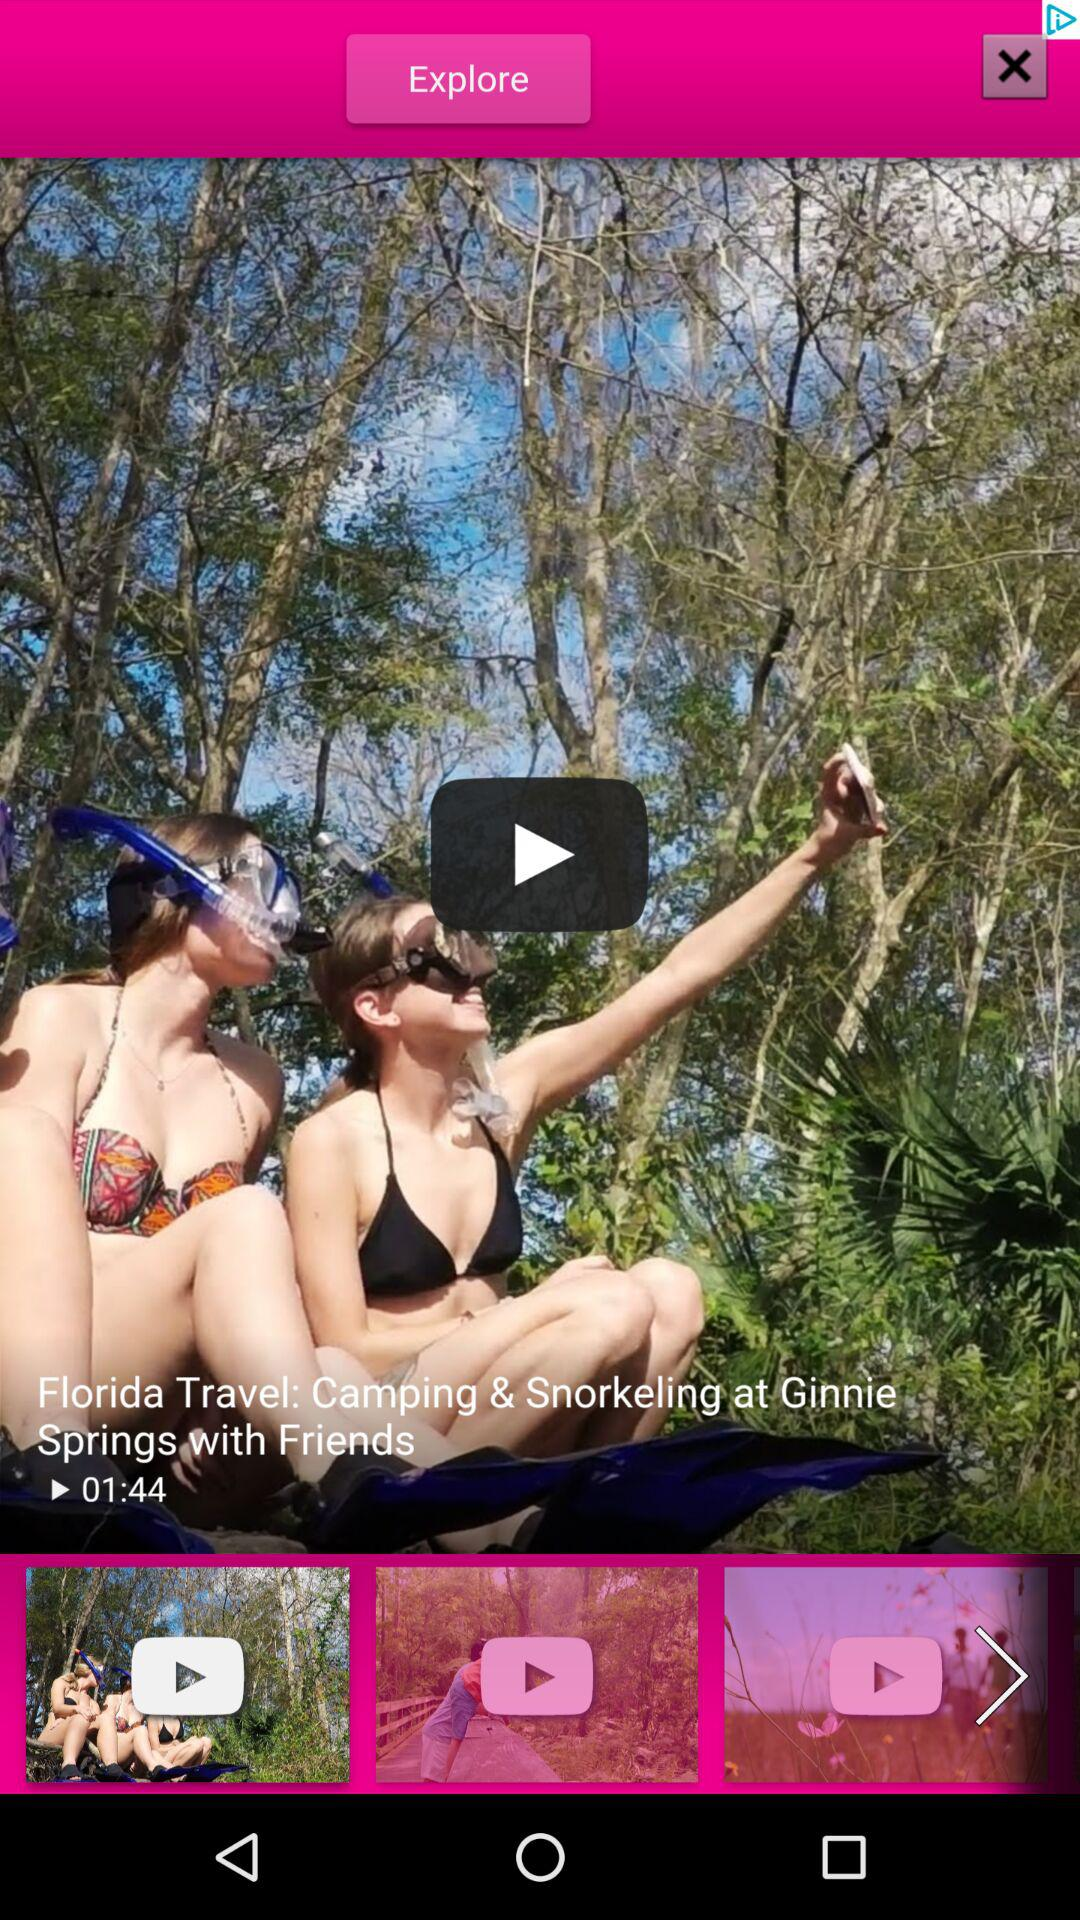What is the duration of the video "Camping & Snorkeling at Ginnie Springs"? The duration of the video is 1 minute 44 seconds. 